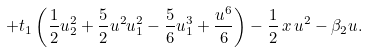Convert formula to latex. <formula><loc_0><loc_0><loc_500><loc_500>+ t _ { 1 } \left ( \frac { 1 } { 2 } u _ { 2 } ^ { 2 } + \frac { 5 } { 2 } u ^ { 2 } u _ { 1 } ^ { 2 } - \frac { 5 } { 6 } u _ { 1 } ^ { 3 } + \frac { u ^ { 6 } } { 6 } \right ) - \frac { 1 } { 2 } \, x \, u ^ { 2 } - \beta _ { 2 } u .</formula> 